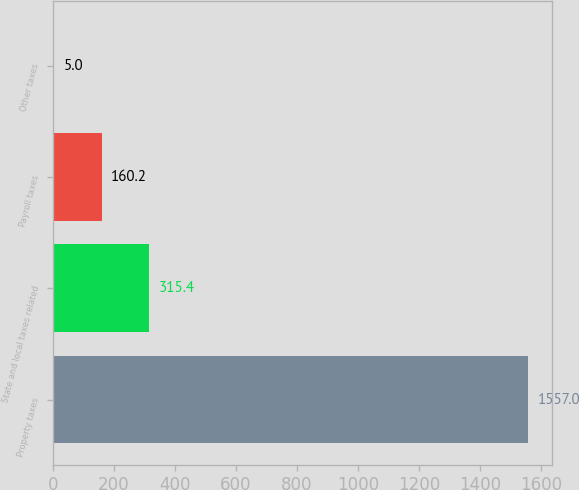Convert chart to OTSL. <chart><loc_0><loc_0><loc_500><loc_500><bar_chart><fcel>Property taxes<fcel>State and local taxes related<fcel>Payroll taxes<fcel>Other taxes<nl><fcel>1557<fcel>315.4<fcel>160.2<fcel>5<nl></chart> 